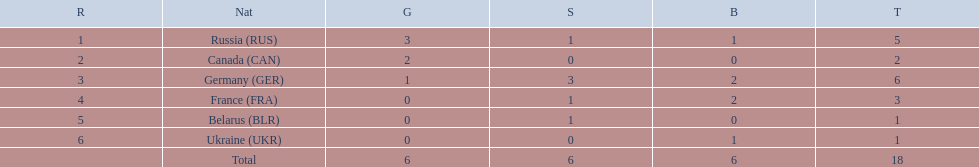Who had a larger total medal count, france or canada? France. 